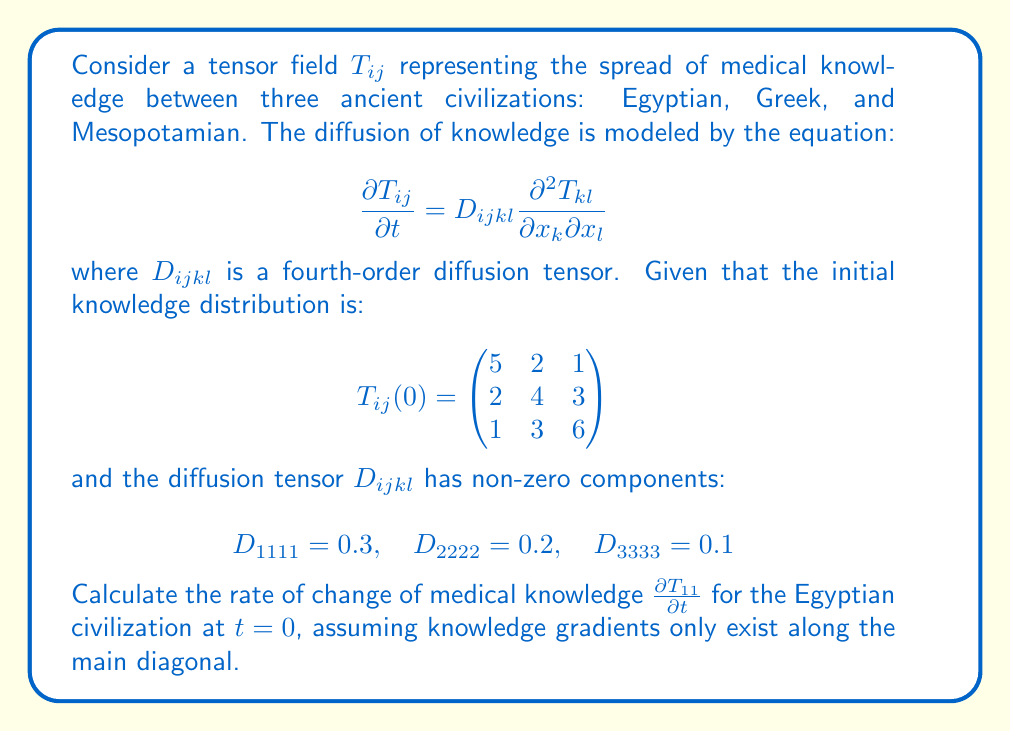Help me with this question. To solve this problem, we'll follow these steps:

1) The given equation is:
   $$\frac{\partial T_{ij}}{\partial t} = D_{ijkl} \frac{\partial^2 T_{kl}}{\partial x_k \partial x_l}$$

2) We're asked to calculate $\frac{\partial T_{11}}{\partial t}$, so we'll focus on the case where $i=j=1$.

3) The assumption that knowledge gradients only exist along the main diagonal means we only need to consider cases where $k=l$.

4) Expanding the right-hand side of the equation:
   $$\frac{\partial T_{11}}{\partial t} = D_{1111} \frac{\partial^2 T_{11}}{\partial x_1^2} + D_{1122} \frac{\partial^2 T_{22}}{\partial x_2^2} + D_{1133} \frac{\partial^2 T_{33}}{\partial x_3^2}$$

5) We're given that $D_{1122} = D_{1133} = 0$, so our equation simplifies to:
   $$\frac{\partial T_{11}}{\partial t} = D_{1111} \frac{\partial^2 T_{11}}{\partial x_1^2}$$

6) We know $D_{1111} = 0.3$, so we just need to calculate $\frac{\partial^2 T_{11}}{\partial x_1^2}$.

7) To approximate the second derivative, we can use the central difference formula:
   $$\frac{\partial^2 T_{11}}{\partial x_1^2} \approx \frac{T_{11}(x_1+\Delta x) - 2T_{11}(x_1) + T_{11}(x_1-\Delta x)}{(\Delta x)^2}$$

8) From the given matrix, we can see that $T_{11} = 5$. The "neighboring" values along the main diagonal are 4 and 6.

9) Assuming $\Delta x = 1$ (since we're moving one step in the matrix), we get:
   $$\frac{\partial^2 T_{11}}{\partial x_1^2} \approx \frac{4 - 2(5) + 6}{1^2} = 0$$

10) Therefore:
    $$\frac{\partial T_{11}}{\partial t} = 0.3 \cdot 0 = 0$$

Thus, at $t=0$, the rate of change of medical knowledge for the Egyptian civilization is 0.
Answer: $0$ 